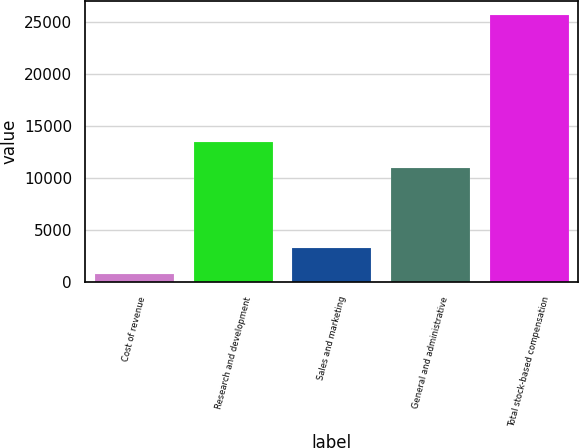<chart> <loc_0><loc_0><loc_500><loc_500><bar_chart><fcel>Cost of revenue<fcel>Research and development<fcel>Sales and marketing<fcel>General and administrative<fcel>Total stock-based compensation<nl><fcel>800<fcel>13467.1<fcel>3294.1<fcel>10973<fcel>25741<nl></chart> 